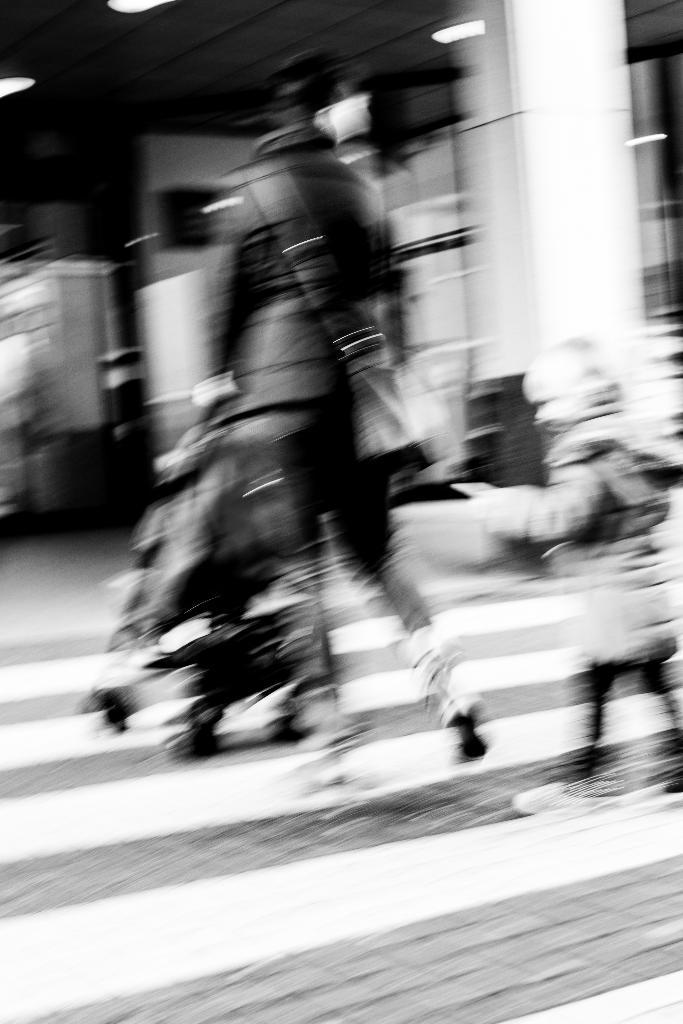Who or what can be seen in the image? There are people in the image. What is associated with the people in the image? There is a stroller in the image. What can be seen illuminating the scene? There are lights in the image. Can you describe any other objects present in the image? There are unspecified objects in the image. What type of lettuce is being used to iron the clothes in the image? There is no lettuce or ironing activity present in the image. 